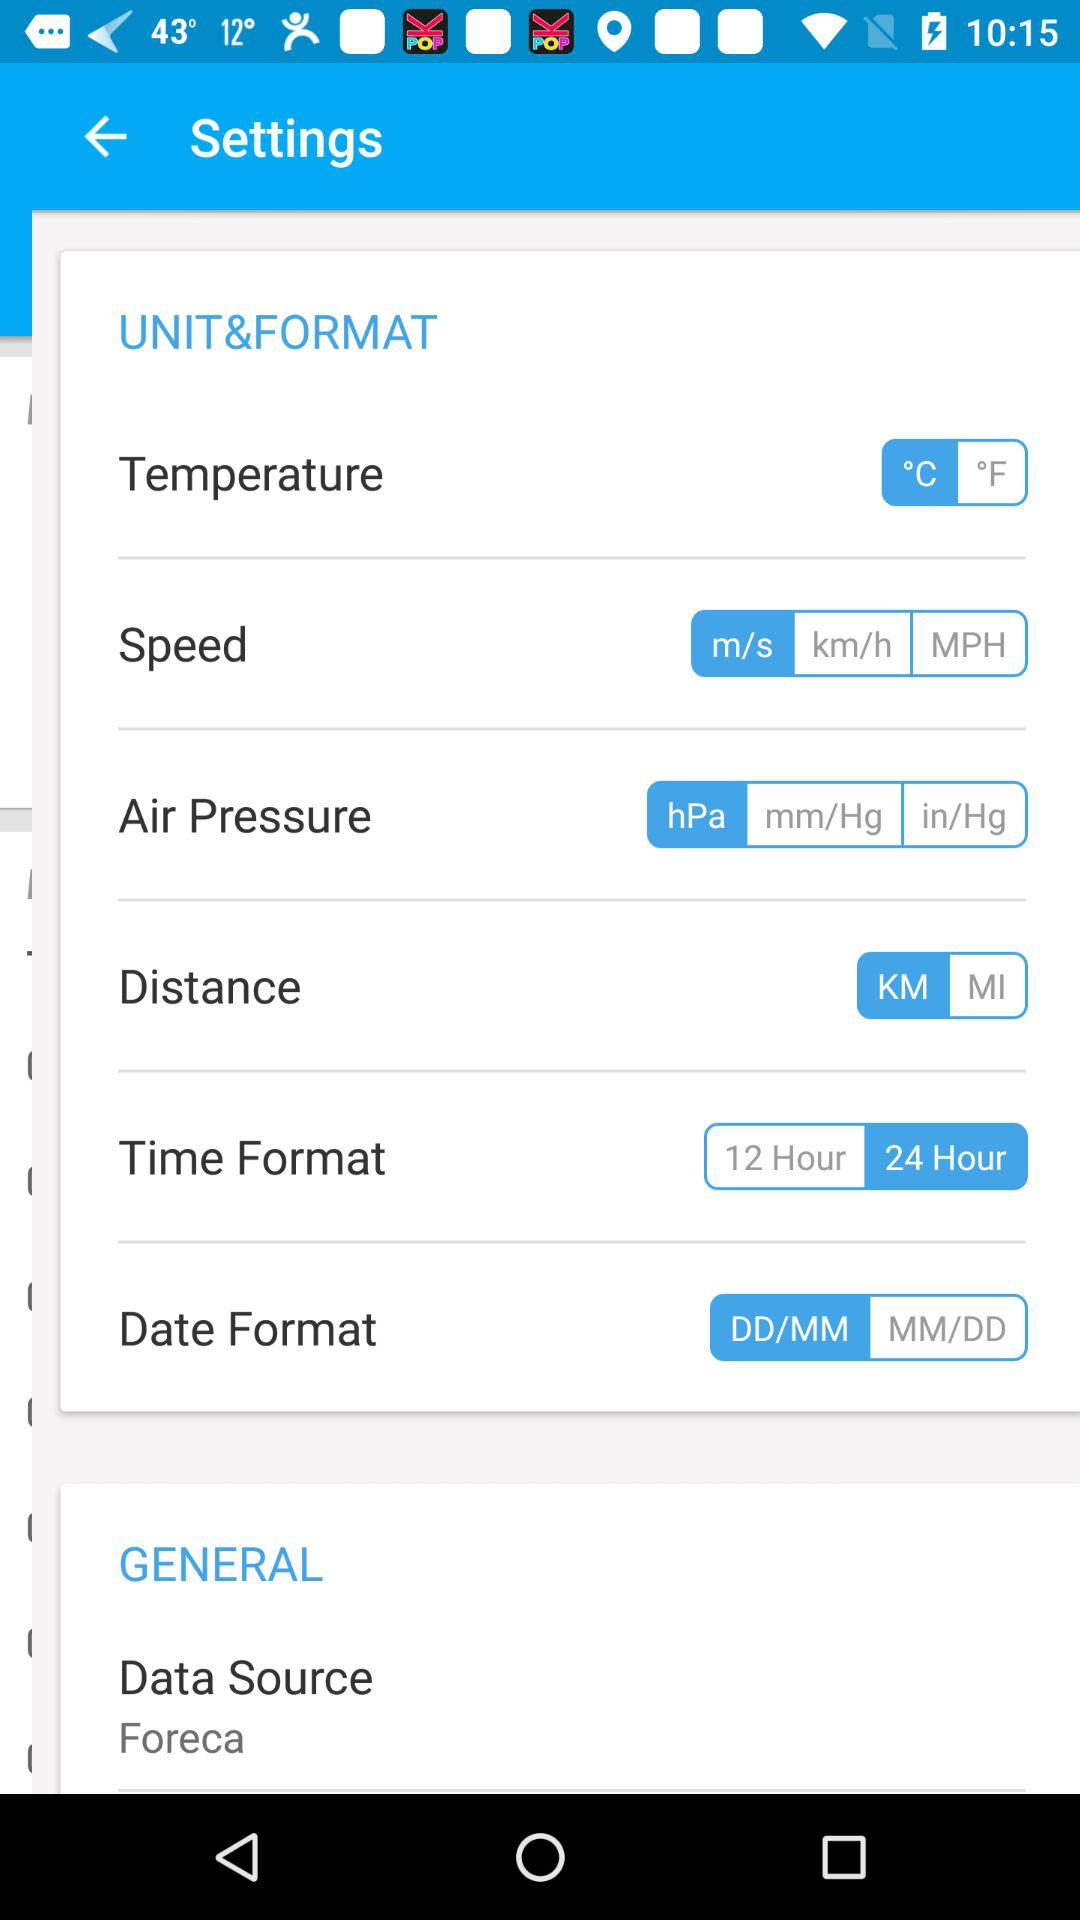Which speed unit is selected? The selected speed unit is m/s. 